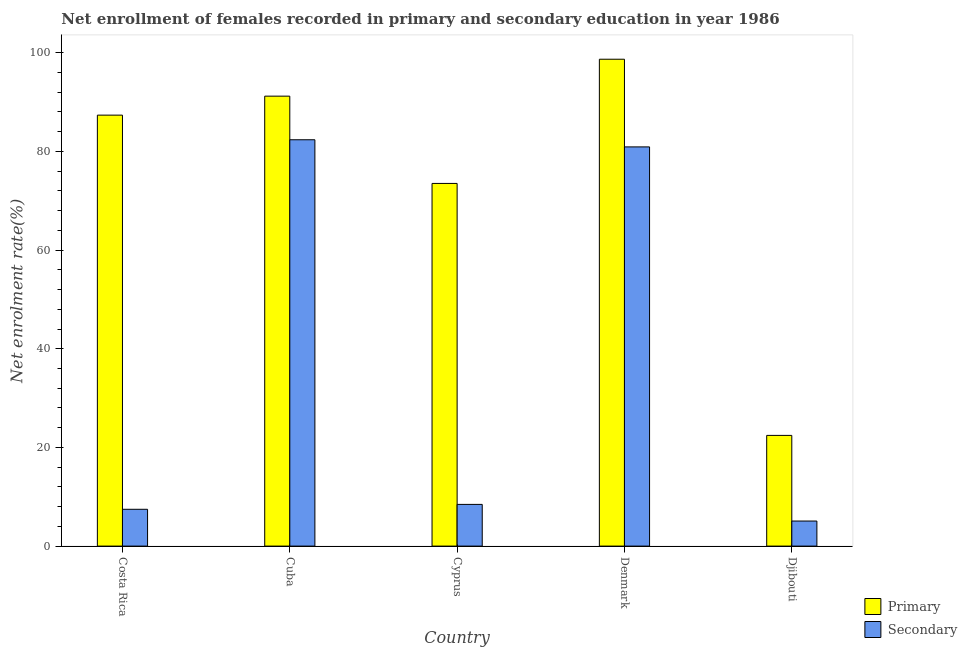How many different coloured bars are there?
Keep it short and to the point. 2. How many groups of bars are there?
Give a very brief answer. 5. Are the number of bars per tick equal to the number of legend labels?
Provide a short and direct response. Yes. What is the label of the 5th group of bars from the left?
Give a very brief answer. Djibouti. In how many cases, is the number of bars for a given country not equal to the number of legend labels?
Make the answer very short. 0. What is the enrollment rate in secondary education in Denmark?
Keep it short and to the point. 80.91. Across all countries, what is the maximum enrollment rate in secondary education?
Give a very brief answer. 82.36. Across all countries, what is the minimum enrollment rate in primary education?
Make the answer very short. 22.44. In which country was the enrollment rate in secondary education maximum?
Keep it short and to the point. Cuba. In which country was the enrollment rate in secondary education minimum?
Your answer should be compact. Djibouti. What is the total enrollment rate in primary education in the graph?
Offer a terse response. 373.17. What is the difference between the enrollment rate in secondary education in Cuba and that in Denmark?
Make the answer very short. 1.45. What is the difference between the enrollment rate in secondary education in Cuba and the enrollment rate in primary education in Cyprus?
Offer a terse response. 8.85. What is the average enrollment rate in primary education per country?
Make the answer very short. 74.63. What is the difference between the enrollment rate in primary education and enrollment rate in secondary education in Djibouti?
Provide a short and direct response. 17.36. What is the ratio of the enrollment rate in secondary education in Costa Rica to that in Cyprus?
Your answer should be very brief. 0.88. What is the difference between the highest and the second highest enrollment rate in primary education?
Offer a very short reply. 7.49. What is the difference between the highest and the lowest enrollment rate in secondary education?
Make the answer very short. 77.28. Is the sum of the enrollment rate in secondary education in Denmark and Djibouti greater than the maximum enrollment rate in primary education across all countries?
Give a very brief answer. No. What does the 2nd bar from the left in Cyprus represents?
Your answer should be very brief. Secondary. What does the 2nd bar from the right in Djibouti represents?
Offer a terse response. Primary. How many bars are there?
Give a very brief answer. 10. Are all the bars in the graph horizontal?
Your answer should be very brief. No. How many countries are there in the graph?
Your answer should be compact. 5. Are the values on the major ticks of Y-axis written in scientific E-notation?
Give a very brief answer. No. Does the graph contain any zero values?
Your response must be concise. No. How are the legend labels stacked?
Keep it short and to the point. Vertical. What is the title of the graph?
Give a very brief answer. Net enrollment of females recorded in primary and secondary education in year 1986. Does "Taxes on exports" appear as one of the legend labels in the graph?
Provide a succinct answer. No. What is the label or title of the X-axis?
Make the answer very short. Country. What is the label or title of the Y-axis?
Ensure brevity in your answer.  Net enrolment rate(%). What is the Net enrolment rate(%) in Primary in Costa Rica?
Your answer should be compact. 87.35. What is the Net enrolment rate(%) of Secondary in Costa Rica?
Provide a short and direct response. 7.46. What is the Net enrolment rate(%) of Primary in Cuba?
Give a very brief answer. 91.2. What is the Net enrolment rate(%) of Secondary in Cuba?
Offer a very short reply. 82.36. What is the Net enrolment rate(%) in Primary in Cyprus?
Provide a short and direct response. 73.51. What is the Net enrolment rate(%) of Secondary in Cyprus?
Ensure brevity in your answer.  8.45. What is the Net enrolment rate(%) in Primary in Denmark?
Your answer should be compact. 98.68. What is the Net enrolment rate(%) in Secondary in Denmark?
Keep it short and to the point. 80.91. What is the Net enrolment rate(%) in Primary in Djibouti?
Offer a very short reply. 22.44. What is the Net enrolment rate(%) in Secondary in Djibouti?
Offer a terse response. 5.08. Across all countries, what is the maximum Net enrolment rate(%) of Primary?
Your answer should be very brief. 98.68. Across all countries, what is the maximum Net enrolment rate(%) in Secondary?
Offer a very short reply. 82.36. Across all countries, what is the minimum Net enrolment rate(%) of Primary?
Your response must be concise. 22.44. Across all countries, what is the minimum Net enrolment rate(%) in Secondary?
Keep it short and to the point. 5.08. What is the total Net enrolment rate(%) in Primary in the graph?
Offer a terse response. 373.17. What is the total Net enrolment rate(%) in Secondary in the graph?
Ensure brevity in your answer.  184.26. What is the difference between the Net enrolment rate(%) of Primary in Costa Rica and that in Cuba?
Make the answer very short. -3.85. What is the difference between the Net enrolment rate(%) of Secondary in Costa Rica and that in Cuba?
Your response must be concise. -74.9. What is the difference between the Net enrolment rate(%) in Primary in Costa Rica and that in Cyprus?
Make the answer very short. 13.84. What is the difference between the Net enrolment rate(%) of Secondary in Costa Rica and that in Cyprus?
Give a very brief answer. -0.99. What is the difference between the Net enrolment rate(%) in Primary in Costa Rica and that in Denmark?
Offer a very short reply. -11.33. What is the difference between the Net enrolment rate(%) in Secondary in Costa Rica and that in Denmark?
Your answer should be compact. -73.45. What is the difference between the Net enrolment rate(%) of Primary in Costa Rica and that in Djibouti?
Keep it short and to the point. 64.91. What is the difference between the Net enrolment rate(%) of Secondary in Costa Rica and that in Djibouti?
Your answer should be very brief. 2.38. What is the difference between the Net enrolment rate(%) of Primary in Cuba and that in Cyprus?
Ensure brevity in your answer.  17.69. What is the difference between the Net enrolment rate(%) in Secondary in Cuba and that in Cyprus?
Offer a terse response. 73.91. What is the difference between the Net enrolment rate(%) of Primary in Cuba and that in Denmark?
Provide a short and direct response. -7.49. What is the difference between the Net enrolment rate(%) in Secondary in Cuba and that in Denmark?
Make the answer very short. 1.45. What is the difference between the Net enrolment rate(%) of Primary in Cuba and that in Djibouti?
Offer a terse response. 68.76. What is the difference between the Net enrolment rate(%) of Secondary in Cuba and that in Djibouti?
Give a very brief answer. 77.28. What is the difference between the Net enrolment rate(%) in Primary in Cyprus and that in Denmark?
Offer a very short reply. -25.18. What is the difference between the Net enrolment rate(%) of Secondary in Cyprus and that in Denmark?
Provide a short and direct response. -72.46. What is the difference between the Net enrolment rate(%) of Primary in Cyprus and that in Djibouti?
Provide a succinct answer. 51.07. What is the difference between the Net enrolment rate(%) of Secondary in Cyprus and that in Djibouti?
Ensure brevity in your answer.  3.37. What is the difference between the Net enrolment rate(%) of Primary in Denmark and that in Djibouti?
Give a very brief answer. 76.25. What is the difference between the Net enrolment rate(%) of Secondary in Denmark and that in Djibouti?
Ensure brevity in your answer.  75.83. What is the difference between the Net enrolment rate(%) of Primary in Costa Rica and the Net enrolment rate(%) of Secondary in Cuba?
Give a very brief answer. 4.99. What is the difference between the Net enrolment rate(%) of Primary in Costa Rica and the Net enrolment rate(%) of Secondary in Cyprus?
Give a very brief answer. 78.9. What is the difference between the Net enrolment rate(%) in Primary in Costa Rica and the Net enrolment rate(%) in Secondary in Denmark?
Give a very brief answer. 6.44. What is the difference between the Net enrolment rate(%) of Primary in Costa Rica and the Net enrolment rate(%) of Secondary in Djibouti?
Make the answer very short. 82.27. What is the difference between the Net enrolment rate(%) in Primary in Cuba and the Net enrolment rate(%) in Secondary in Cyprus?
Ensure brevity in your answer.  82.74. What is the difference between the Net enrolment rate(%) of Primary in Cuba and the Net enrolment rate(%) of Secondary in Denmark?
Ensure brevity in your answer.  10.29. What is the difference between the Net enrolment rate(%) of Primary in Cuba and the Net enrolment rate(%) of Secondary in Djibouti?
Make the answer very short. 86.12. What is the difference between the Net enrolment rate(%) of Primary in Cyprus and the Net enrolment rate(%) of Secondary in Denmark?
Keep it short and to the point. -7.4. What is the difference between the Net enrolment rate(%) of Primary in Cyprus and the Net enrolment rate(%) of Secondary in Djibouti?
Ensure brevity in your answer.  68.43. What is the difference between the Net enrolment rate(%) in Primary in Denmark and the Net enrolment rate(%) in Secondary in Djibouti?
Offer a terse response. 93.6. What is the average Net enrolment rate(%) of Primary per country?
Offer a very short reply. 74.63. What is the average Net enrolment rate(%) of Secondary per country?
Offer a very short reply. 36.85. What is the difference between the Net enrolment rate(%) in Primary and Net enrolment rate(%) in Secondary in Costa Rica?
Offer a terse response. 79.89. What is the difference between the Net enrolment rate(%) in Primary and Net enrolment rate(%) in Secondary in Cuba?
Offer a very short reply. 8.84. What is the difference between the Net enrolment rate(%) in Primary and Net enrolment rate(%) in Secondary in Cyprus?
Your answer should be very brief. 65.05. What is the difference between the Net enrolment rate(%) in Primary and Net enrolment rate(%) in Secondary in Denmark?
Offer a terse response. 17.77. What is the difference between the Net enrolment rate(%) in Primary and Net enrolment rate(%) in Secondary in Djibouti?
Your response must be concise. 17.36. What is the ratio of the Net enrolment rate(%) in Primary in Costa Rica to that in Cuba?
Your answer should be compact. 0.96. What is the ratio of the Net enrolment rate(%) in Secondary in Costa Rica to that in Cuba?
Your answer should be very brief. 0.09. What is the ratio of the Net enrolment rate(%) in Primary in Costa Rica to that in Cyprus?
Offer a terse response. 1.19. What is the ratio of the Net enrolment rate(%) of Secondary in Costa Rica to that in Cyprus?
Offer a terse response. 0.88. What is the ratio of the Net enrolment rate(%) of Primary in Costa Rica to that in Denmark?
Your response must be concise. 0.89. What is the ratio of the Net enrolment rate(%) in Secondary in Costa Rica to that in Denmark?
Your answer should be very brief. 0.09. What is the ratio of the Net enrolment rate(%) of Primary in Costa Rica to that in Djibouti?
Ensure brevity in your answer.  3.89. What is the ratio of the Net enrolment rate(%) in Secondary in Costa Rica to that in Djibouti?
Provide a succinct answer. 1.47. What is the ratio of the Net enrolment rate(%) of Primary in Cuba to that in Cyprus?
Provide a short and direct response. 1.24. What is the ratio of the Net enrolment rate(%) in Secondary in Cuba to that in Cyprus?
Your response must be concise. 9.74. What is the ratio of the Net enrolment rate(%) in Primary in Cuba to that in Denmark?
Give a very brief answer. 0.92. What is the ratio of the Net enrolment rate(%) of Secondary in Cuba to that in Denmark?
Your answer should be very brief. 1.02. What is the ratio of the Net enrolment rate(%) in Primary in Cuba to that in Djibouti?
Provide a short and direct response. 4.06. What is the ratio of the Net enrolment rate(%) in Secondary in Cuba to that in Djibouti?
Offer a terse response. 16.22. What is the ratio of the Net enrolment rate(%) of Primary in Cyprus to that in Denmark?
Your response must be concise. 0.74. What is the ratio of the Net enrolment rate(%) in Secondary in Cyprus to that in Denmark?
Give a very brief answer. 0.1. What is the ratio of the Net enrolment rate(%) in Primary in Cyprus to that in Djibouti?
Provide a succinct answer. 3.28. What is the ratio of the Net enrolment rate(%) of Secondary in Cyprus to that in Djibouti?
Make the answer very short. 1.66. What is the ratio of the Net enrolment rate(%) of Primary in Denmark to that in Djibouti?
Offer a very short reply. 4.4. What is the ratio of the Net enrolment rate(%) of Secondary in Denmark to that in Djibouti?
Ensure brevity in your answer.  15.93. What is the difference between the highest and the second highest Net enrolment rate(%) in Primary?
Your answer should be very brief. 7.49. What is the difference between the highest and the second highest Net enrolment rate(%) in Secondary?
Provide a succinct answer. 1.45. What is the difference between the highest and the lowest Net enrolment rate(%) in Primary?
Your response must be concise. 76.25. What is the difference between the highest and the lowest Net enrolment rate(%) in Secondary?
Your answer should be very brief. 77.28. 